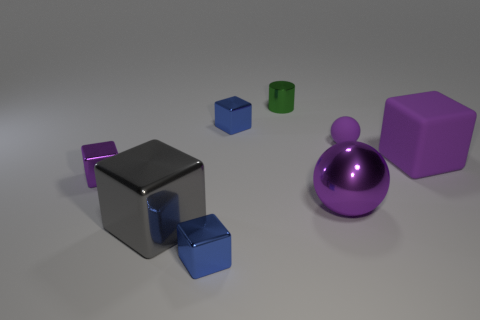Is the number of big purple metallic spheres less than the number of large yellow cylinders?
Make the answer very short. No. Are there any metallic things in front of the green shiny cylinder?
Provide a short and direct response. Yes. Is the big purple sphere made of the same material as the large gray thing?
Your answer should be compact. Yes. What is the color of the rubber thing that is the same shape as the big purple metal object?
Ensure brevity in your answer.  Purple. There is a rubber object that is behind the purple matte cube; is its color the same as the large rubber block?
Your response must be concise. Yes. What is the shape of the tiny metal object that is the same color as the big ball?
Your answer should be very brief. Cube. How many small things are the same material as the tiny cylinder?
Ensure brevity in your answer.  3. What number of tiny blue metal blocks are in front of the green object?
Your answer should be very brief. 2. How big is the purple shiny cube?
Your answer should be compact. Small. There is a metal cube that is the same size as the purple metallic sphere; what color is it?
Your answer should be very brief. Gray. 